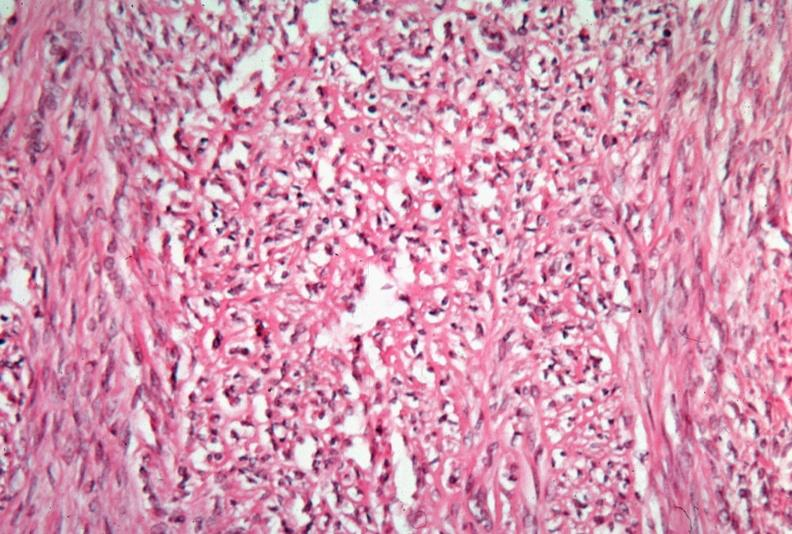where is this from?
Answer the question using a single word or phrase. Female reproductive system 